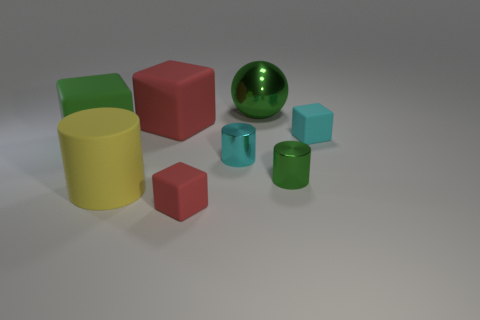Subtract 1 cubes. How many cubes are left? 3 Subtract all gray blocks. Subtract all blue balls. How many blocks are left? 4 Add 1 red metal balls. How many objects exist? 9 Subtract all cylinders. How many objects are left? 5 Add 5 tiny shiny cylinders. How many tiny shiny cylinders exist? 7 Subtract 1 cyan blocks. How many objects are left? 7 Subtract all small cyan cubes. Subtract all big red cubes. How many objects are left? 6 Add 3 tiny things. How many tiny things are left? 7 